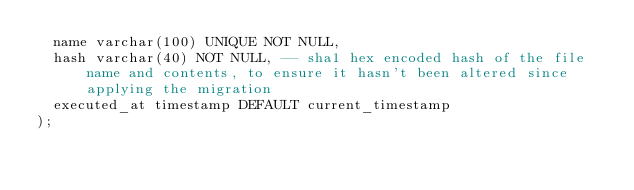Convert code to text. <code><loc_0><loc_0><loc_500><loc_500><_SQL_>  name varchar(100) UNIQUE NOT NULL,
  hash varchar(40) NOT NULL, -- sha1 hex encoded hash of the file name and contents, to ensure it hasn't been altered since applying the migration
  executed_at timestamp DEFAULT current_timestamp
);
</code> 